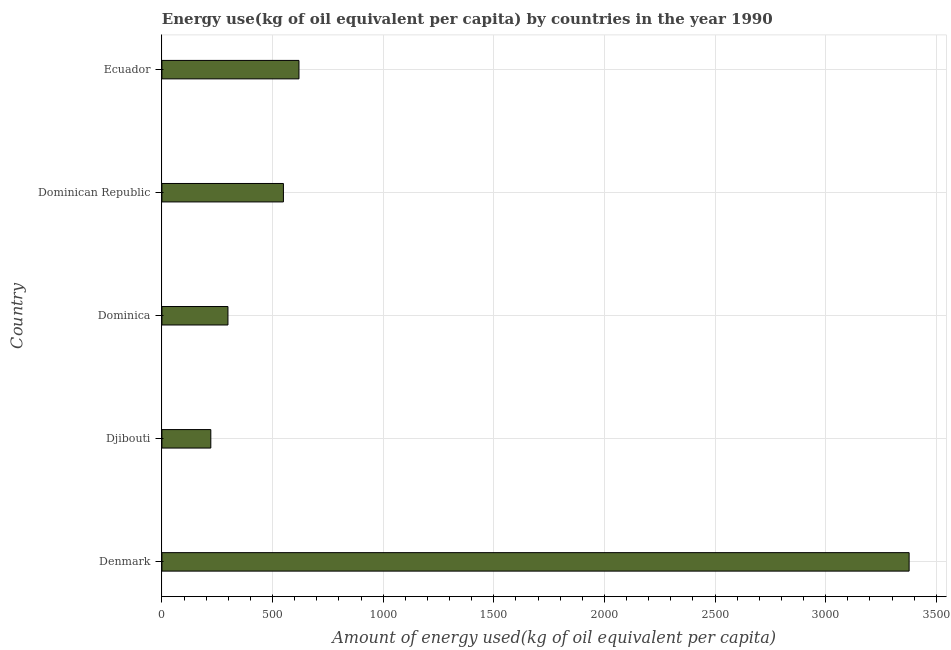Does the graph contain any zero values?
Make the answer very short. No. What is the title of the graph?
Make the answer very short. Energy use(kg of oil equivalent per capita) by countries in the year 1990. What is the label or title of the X-axis?
Offer a terse response. Amount of energy used(kg of oil equivalent per capita). What is the amount of energy used in Djibouti?
Your answer should be very brief. 221.05. Across all countries, what is the maximum amount of energy used?
Keep it short and to the point. 3377.01. Across all countries, what is the minimum amount of energy used?
Your answer should be compact. 221.05. In which country was the amount of energy used minimum?
Ensure brevity in your answer.  Djibouti. What is the sum of the amount of energy used?
Give a very brief answer. 5065.24. What is the difference between the amount of energy used in Denmark and Ecuador?
Offer a very short reply. 2757.51. What is the average amount of energy used per country?
Your answer should be compact. 1013.05. What is the median amount of energy used?
Provide a succinct answer. 549.2. What is the ratio of the amount of energy used in Denmark to that in Dominican Republic?
Your answer should be very brief. 6.15. Is the amount of energy used in Denmark less than that in Dominica?
Give a very brief answer. No. Is the difference between the amount of energy used in Djibouti and Dominica greater than the difference between any two countries?
Offer a terse response. No. What is the difference between the highest and the second highest amount of energy used?
Keep it short and to the point. 2757.51. Is the sum of the amount of energy used in Dominica and Dominican Republic greater than the maximum amount of energy used across all countries?
Offer a terse response. No. What is the difference between the highest and the lowest amount of energy used?
Make the answer very short. 3155.96. Are all the bars in the graph horizontal?
Give a very brief answer. Yes. How many countries are there in the graph?
Your response must be concise. 5. What is the difference between two consecutive major ticks on the X-axis?
Ensure brevity in your answer.  500. What is the Amount of energy used(kg of oil equivalent per capita) in Denmark?
Your response must be concise. 3377.01. What is the Amount of energy used(kg of oil equivalent per capita) in Djibouti?
Give a very brief answer. 221.05. What is the Amount of energy used(kg of oil equivalent per capita) of Dominica?
Make the answer very short. 298.49. What is the Amount of energy used(kg of oil equivalent per capita) of Dominican Republic?
Your answer should be very brief. 549.2. What is the Amount of energy used(kg of oil equivalent per capita) in Ecuador?
Your answer should be very brief. 619.49. What is the difference between the Amount of energy used(kg of oil equivalent per capita) in Denmark and Djibouti?
Provide a succinct answer. 3155.96. What is the difference between the Amount of energy used(kg of oil equivalent per capita) in Denmark and Dominica?
Offer a very short reply. 3078.51. What is the difference between the Amount of energy used(kg of oil equivalent per capita) in Denmark and Dominican Republic?
Your answer should be compact. 2827.81. What is the difference between the Amount of energy used(kg of oil equivalent per capita) in Denmark and Ecuador?
Your answer should be compact. 2757.51. What is the difference between the Amount of energy used(kg of oil equivalent per capita) in Djibouti and Dominica?
Offer a very short reply. -77.44. What is the difference between the Amount of energy used(kg of oil equivalent per capita) in Djibouti and Dominican Republic?
Offer a very short reply. -328.15. What is the difference between the Amount of energy used(kg of oil equivalent per capita) in Djibouti and Ecuador?
Provide a succinct answer. -398.44. What is the difference between the Amount of energy used(kg of oil equivalent per capita) in Dominica and Dominican Republic?
Your answer should be very brief. -250.7. What is the difference between the Amount of energy used(kg of oil equivalent per capita) in Dominica and Ecuador?
Ensure brevity in your answer.  -321. What is the difference between the Amount of energy used(kg of oil equivalent per capita) in Dominican Republic and Ecuador?
Ensure brevity in your answer.  -70.29. What is the ratio of the Amount of energy used(kg of oil equivalent per capita) in Denmark to that in Djibouti?
Give a very brief answer. 15.28. What is the ratio of the Amount of energy used(kg of oil equivalent per capita) in Denmark to that in Dominica?
Keep it short and to the point. 11.31. What is the ratio of the Amount of energy used(kg of oil equivalent per capita) in Denmark to that in Dominican Republic?
Ensure brevity in your answer.  6.15. What is the ratio of the Amount of energy used(kg of oil equivalent per capita) in Denmark to that in Ecuador?
Your answer should be very brief. 5.45. What is the ratio of the Amount of energy used(kg of oil equivalent per capita) in Djibouti to that in Dominica?
Keep it short and to the point. 0.74. What is the ratio of the Amount of energy used(kg of oil equivalent per capita) in Djibouti to that in Dominican Republic?
Ensure brevity in your answer.  0.4. What is the ratio of the Amount of energy used(kg of oil equivalent per capita) in Djibouti to that in Ecuador?
Your answer should be compact. 0.36. What is the ratio of the Amount of energy used(kg of oil equivalent per capita) in Dominica to that in Dominican Republic?
Ensure brevity in your answer.  0.54. What is the ratio of the Amount of energy used(kg of oil equivalent per capita) in Dominica to that in Ecuador?
Offer a very short reply. 0.48. What is the ratio of the Amount of energy used(kg of oil equivalent per capita) in Dominican Republic to that in Ecuador?
Provide a short and direct response. 0.89. 